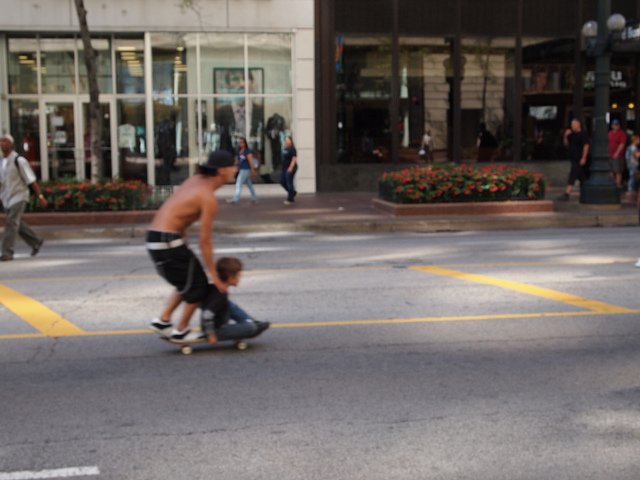<image>What does the window on the right say? The window on the right doesn't have any readable text. However, it might say 'aarp', 'bank' or 'au'. What does the window on the right say? I don't know what the window on the right says. It can be seen 'aarp', 'bank', 'au', or it may say nothing at all. 